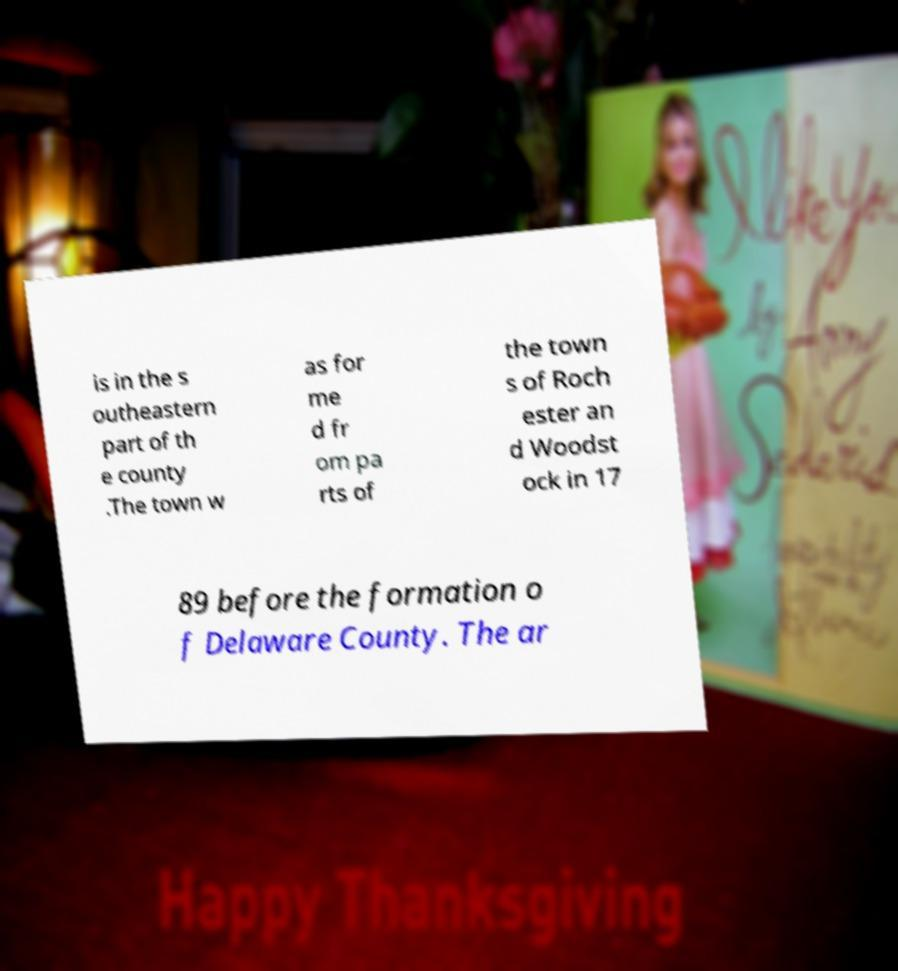Can you accurately transcribe the text from the provided image for me? is in the s outheastern part of th e county .The town w as for me d fr om pa rts of the town s of Roch ester an d Woodst ock in 17 89 before the formation o f Delaware County. The ar 